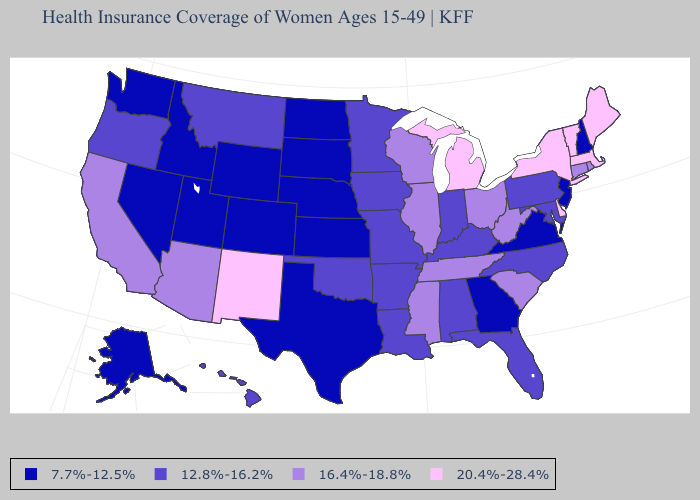Among the states that border Michigan , which have the highest value?
Short answer required. Ohio, Wisconsin. Among the states that border Oregon , which have the lowest value?
Concise answer only. Idaho, Nevada, Washington. What is the highest value in states that border Kansas?
Keep it brief. 12.8%-16.2%. How many symbols are there in the legend?
Give a very brief answer. 4. Name the states that have a value in the range 20.4%-28.4%?
Quick response, please. Delaware, Maine, Massachusetts, Michigan, New Mexico, New York, Vermont. Name the states that have a value in the range 12.8%-16.2%?
Answer briefly. Alabama, Arkansas, Florida, Hawaii, Indiana, Iowa, Kentucky, Louisiana, Maryland, Minnesota, Missouri, Montana, North Carolina, Oklahoma, Oregon, Pennsylvania. Does Mississippi have a higher value than Indiana?
Give a very brief answer. Yes. Name the states that have a value in the range 20.4%-28.4%?
Concise answer only. Delaware, Maine, Massachusetts, Michigan, New Mexico, New York, Vermont. Does Nevada have the highest value in the USA?
Be succinct. No. What is the value of Arkansas?
Give a very brief answer. 12.8%-16.2%. Does Montana have the lowest value in the West?
Concise answer only. No. Name the states that have a value in the range 20.4%-28.4%?
Short answer required. Delaware, Maine, Massachusetts, Michigan, New Mexico, New York, Vermont. Does Maryland have the same value as Michigan?
Quick response, please. No. What is the highest value in states that border Massachusetts?
Be succinct. 20.4%-28.4%. Name the states that have a value in the range 12.8%-16.2%?
Quick response, please. Alabama, Arkansas, Florida, Hawaii, Indiana, Iowa, Kentucky, Louisiana, Maryland, Minnesota, Missouri, Montana, North Carolina, Oklahoma, Oregon, Pennsylvania. 